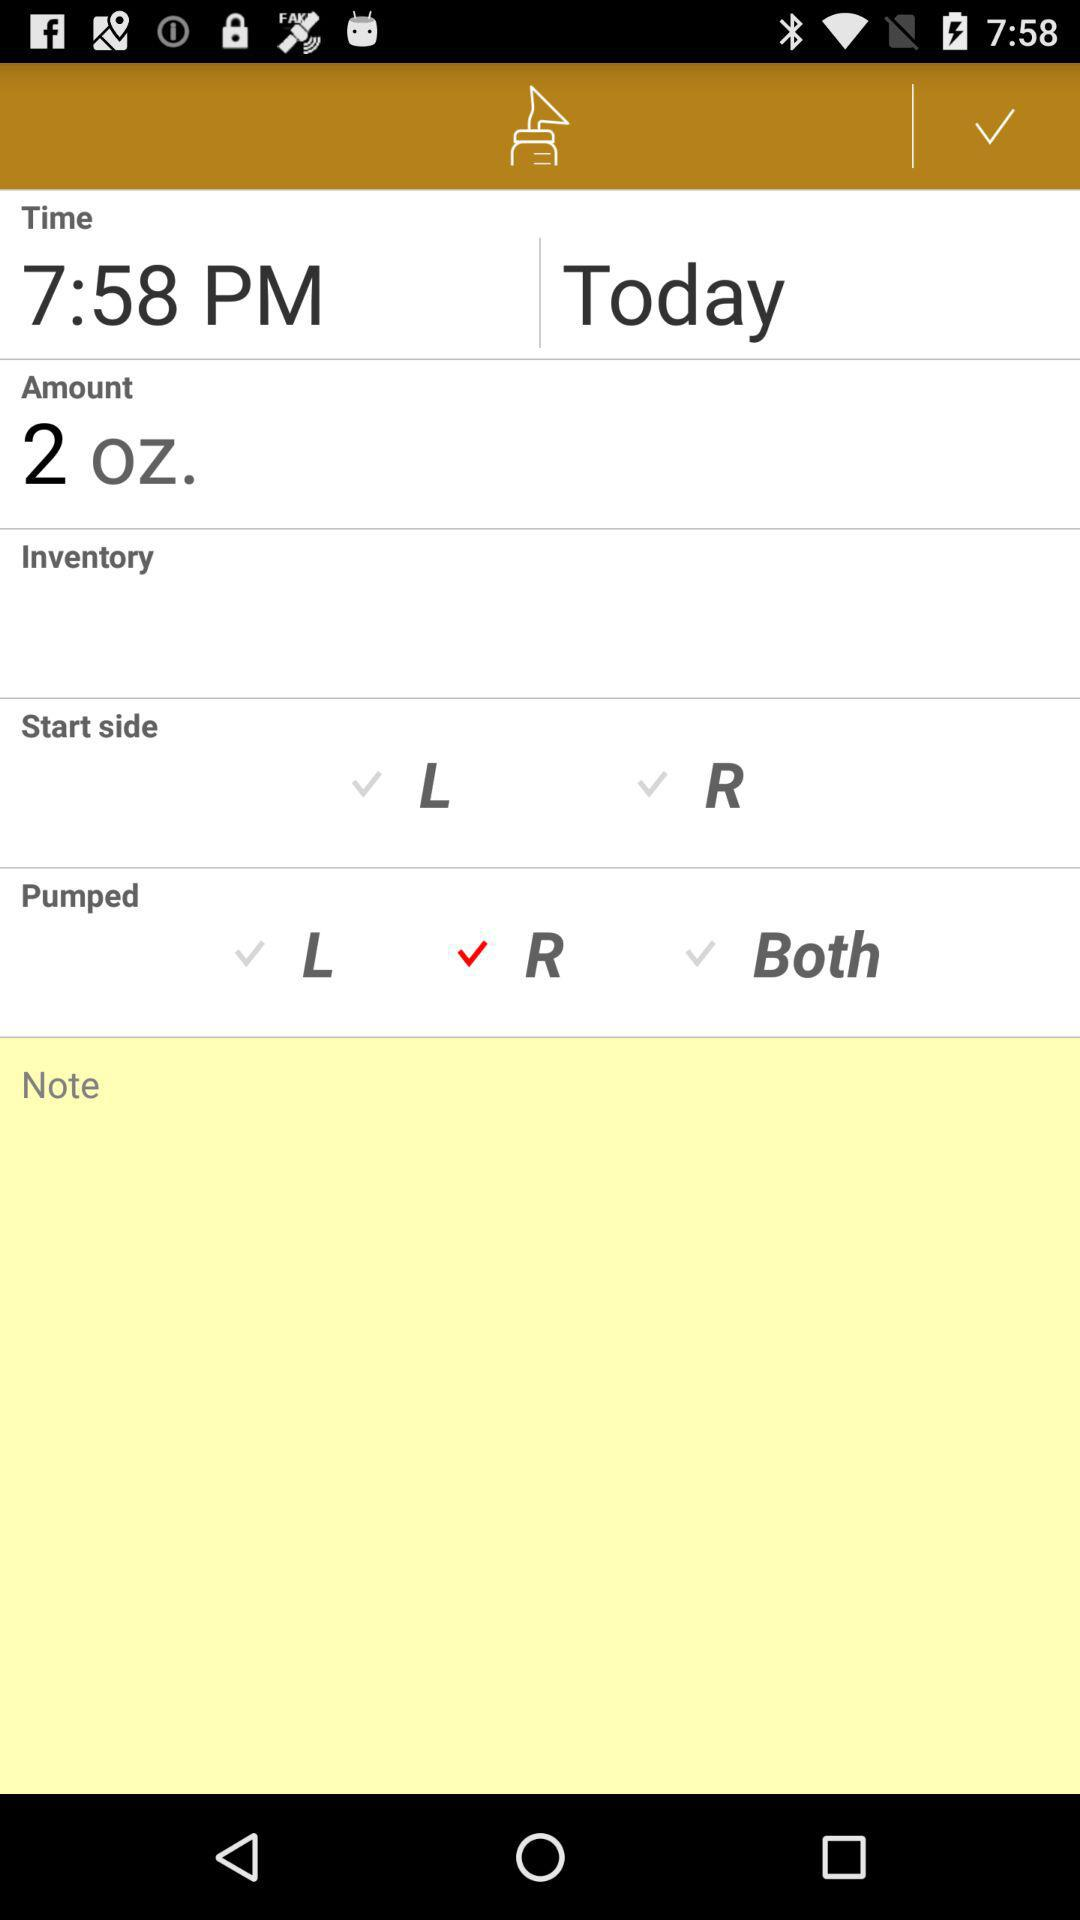What is the amount? The amount is 2 oz. 